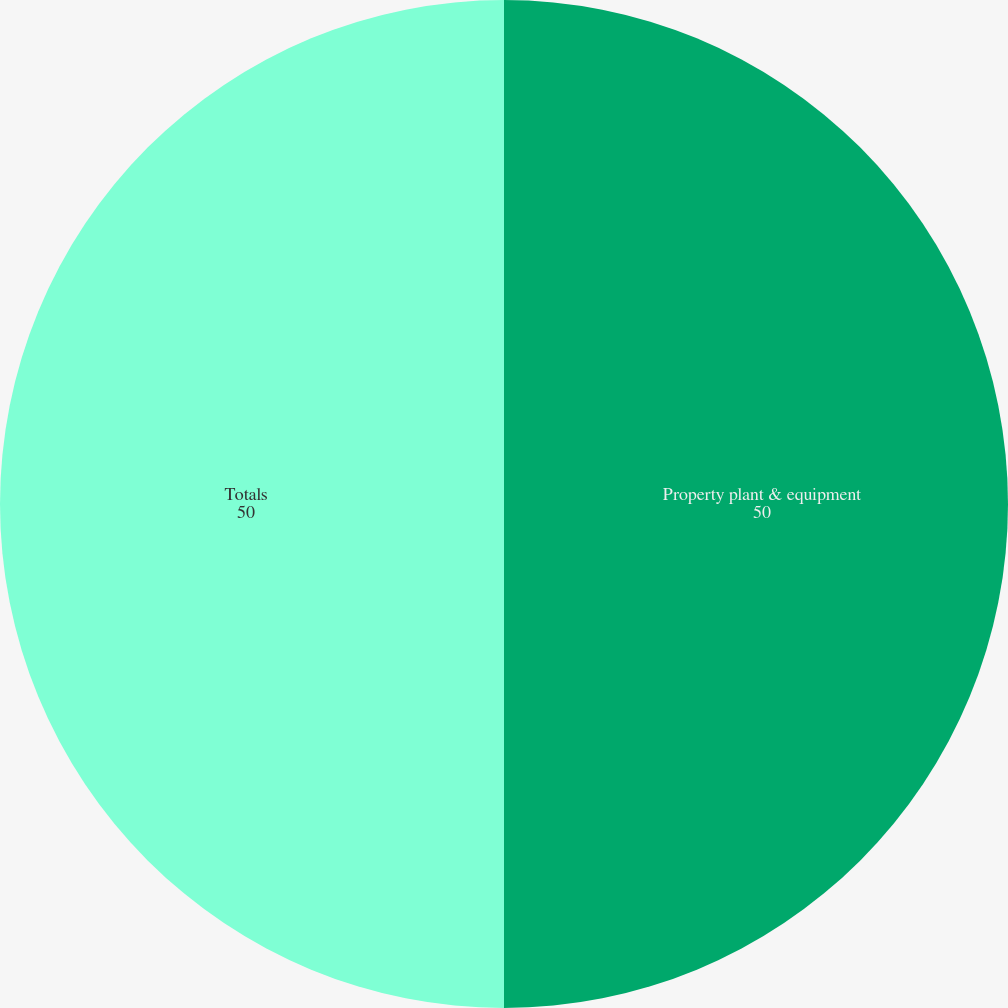<chart> <loc_0><loc_0><loc_500><loc_500><pie_chart><fcel>Property plant & equipment<fcel>Totals<nl><fcel>50.0%<fcel>50.0%<nl></chart> 